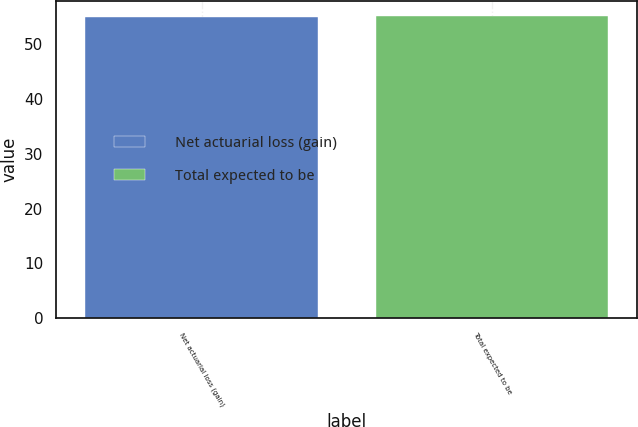Convert chart to OTSL. <chart><loc_0><loc_0><loc_500><loc_500><bar_chart><fcel>Net actuarial loss (gain)<fcel>Total expected to be<nl><fcel>55<fcel>55.1<nl></chart> 